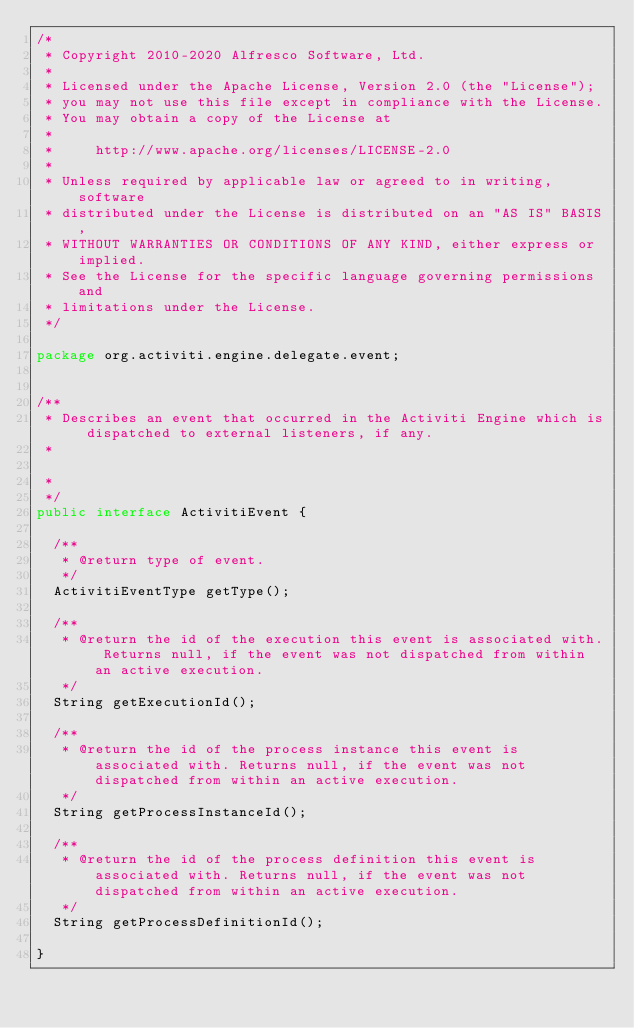Convert code to text. <code><loc_0><loc_0><loc_500><loc_500><_Java_>/*
 * Copyright 2010-2020 Alfresco Software, Ltd.
 *
 * Licensed under the Apache License, Version 2.0 (the "License");
 * you may not use this file except in compliance with the License.
 * You may obtain a copy of the License at
 *
 *     http://www.apache.org/licenses/LICENSE-2.0
 *
 * Unless required by applicable law or agreed to in writing, software
 * distributed under the License is distributed on an "AS IS" BASIS,
 * WITHOUT WARRANTIES OR CONDITIONS OF ANY KIND, either express or implied.
 * See the License for the specific language governing permissions and
 * limitations under the License.
 */

package org.activiti.engine.delegate.event;


/**
 * Describes an event that occurred in the Activiti Engine which is dispatched to external listeners, if any.
 *

 *
 */
public interface ActivitiEvent {

  /**
   * @return type of event.
   */
  ActivitiEventType getType();

  /**
   * @return the id of the execution this event is associated with. Returns null, if the event was not dispatched from within an active execution.
   */
  String getExecutionId();

  /**
   * @return the id of the process instance this event is associated with. Returns null, if the event was not dispatched from within an active execution.
   */
  String getProcessInstanceId();

  /**
   * @return the id of the process definition this event is associated with. Returns null, if the event was not dispatched from within an active execution.
   */
  String getProcessDefinitionId();

}
</code> 